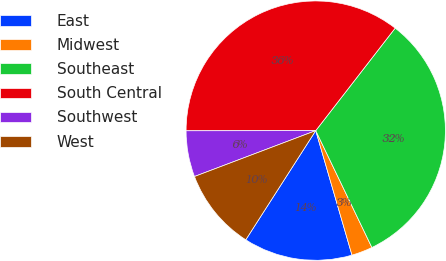Convert chart to OTSL. <chart><loc_0><loc_0><loc_500><loc_500><pie_chart><fcel>East<fcel>Midwest<fcel>Southeast<fcel>South Central<fcel>Southwest<fcel>West<nl><fcel>13.58%<fcel>2.62%<fcel>32.38%<fcel>35.51%<fcel>5.74%<fcel>10.17%<nl></chart> 